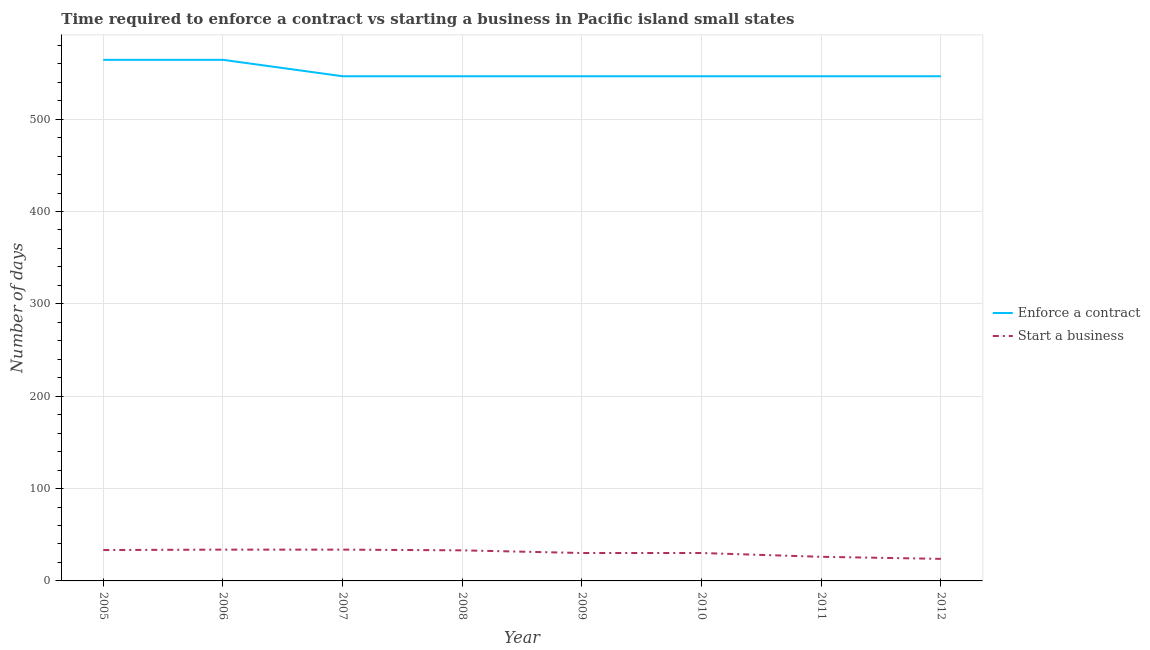How many different coloured lines are there?
Your answer should be compact. 2. Is the number of lines equal to the number of legend labels?
Ensure brevity in your answer.  Yes. What is the number of days to enforece a contract in 2006?
Your answer should be very brief. 564.22. Across all years, what is the maximum number of days to enforece a contract?
Provide a succinct answer. 564.22. Across all years, what is the minimum number of days to start a business?
Offer a terse response. 23.89. In which year was the number of days to enforece a contract maximum?
Make the answer very short. 2005. What is the total number of days to start a business in the graph?
Make the answer very short. 244.78. What is the difference between the number of days to start a business in 2006 and that in 2007?
Provide a succinct answer. 0. What is the difference between the number of days to enforece a contract in 2007 and the number of days to start a business in 2008?
Make the answer very short. 513.33. What is the average number of days to start a business per year?
Provide a short and direct response. 30.6. In the year 2007, what is the difference between the number of days to start a business and number of days to enforece a contract?
Ensure brevity in your answer.  -512.56. What is the ratio of the number of days to start a business in 2010 to that in 2012?
Your answer should be very brief. 1.27. What is the difference between the highest and the lowest number of days to enforece a contract?
Ensure brevity in your answer.  17.78. In how many years, is the number of days to enforece a contract greater than the average number of days to enforece a contract taken over all years?
Ensure brevity in your answer.  2. Is the sum of the number of days to enforece a contract in 2008 and 2012 greater than the maximum number of days to start a business across all years?
Provide a succinct answer. Yes. Is the number of days to start a business strictly greater than the number of days to enforece a contract over the years?
Give a very brief answer. No. Is the number of days to start a business strictly less than the number of days to enforece a contract over the years?
Make the answer very short. Yes. How many lines are there?
Make the answer very short. 2. How many years are there in the graph?
Your response must be concise. 8. What is the difference between two consecutive major ticks on the Y-axis?
Give a very brief answer. 100. Are the values on the major ticks of Y-axis written in scientific E-notation?
Keep it short and to the point. No. Does the graph contain any zero values?
Your answer should be compact. No. Where does the legend appear in the graph?
Provide a short and direct response. Center right. What is the title of the graph?
Make the answer very short. Time required to enforce a contract vs starting a business in Pacific island small states. What is the label or title of the X-axis?
Offer a terse response. Year. What is the label or title of the Y-axis?
Your response must be concise. Number of days. What is the Number of days of Enforce a contract in 2005?
Offer a terse response. 564.22. What is the Number of days in Start a business in 2005?
Your response must be concise. 33.44. What is the Number of days in Enforce a contract in 2006?
Keep it short and to the point. 564.22. What is the Number of days in Start a business in 2006?
Offer a terse response. 33.89. What is the Number of days of Enforce a contract in 2007?
Offer a terse response. 546.44. What is the Number of days in Start a business in 2007?
Ensure brevity in your answer.  33.89. What is the Number of days in Enforce a contract in 2008?
Your answer should be very brief. 546.44. What is the Number of days of Start a business in 2008?
Ensure brevity in your answer.  33.11. What is the Number of days in Enforce a contract in 2009?
Provide a succinct answer. 546.44. What is the Number of days of Start a business in 2009?
Provide a succinct answer. 30.22. What is the Number of days in Enforce a contract in 2010?
Your response must be concise. 546.44. What is the Number of days in Start a business in 2010?
Offer a very short reply. 30.22. What is the Number of days of Enforce a contract in 2011?
Your response must be concise. 546.44. What is the Number of days of Start a business in 2011?
Provide a succinct answer. 26.11. What is the Number of days in Enforce a contract in 2012?
Your answer should be very brief. 546.44. What is the Number of days of Start a business in 2012?
Offer a very short reply. 23.89. Across all years, what is the maximum Number of days in Enforce a contract?
Make the answer very short. 564.22. Across all years, what is the maximum Number of days of Start a business?
Give a very brief answer. 33.89. Across all years, what is the minimum Number of days in Enforce a contract?
Your answer should be very brief. 546.44. Across all years, what is the minimum Number of days of Start a business?
Make the answer very short. 23.89. What is the total Number of days of Enforce a contract in the graph?
Your answer should be very brief. 4407.11. What is the total Number of days in Start a business in the graph?
Your answer should be compact. 244.78. What is the difference between the Number of days of Start a business in 2005 and that in 2006?
Offer a very short reply. -0.44. What is the difference between the Number of days in Enforce a contract in 2005 and that in 2007?
Offer a very short reply. 17.78. What is the difference between the Number of days of Start a business in 2005 and that in 2007?
Ensure brevity in your answer.  -0.44. What is the difference between the Number of days in Enforce a contract in 2005 and that in 2008?
Your answer should be compact. 17.78. What is the difference between the Number of days of Enforce a contract in 2005 and that in 2009?
Give a very brief answer. 17.78. What is the difference between the Number of days in Start a business in 2005 and that in 2009?
Give a very brief answer. 3.22. What is the difference between the Number of days of Enforce a contract in 2005 and that in 2010?
Offer a terse response. 17.78. What is the difference between the Number of days of Start a business in 2005 and that in 2010?
Provide a succinct answer. 3.22. What is the difference between the Number of days in Enforce a contract in 2005 and that in 2011?
Ensure brevity in your answer.  17.78. What is the difference between the Number of days of Start a business in 2005 and that in 2011?
Provide a short and direct response. 7.33. What is the difference between the Number of days of Enforce a contract in 2005 and that in 2012?
Offer a terse response. 17.78. What is the difference between the Number of days of Start a business in 2005 and that in 2012?
Your answer should be very brief. 9.56. What is the difference between the Number of days of Enforce a contract in 2006 and that in 2007?
Your answer should be compact. 17.78. What is the difference between the Number of days of Start a business in 2006 and that in 2007?
Provide a succinct answer. 0. What is the difference between the Number of days in Enforce a contract in 2006 and that in 2008?
Make the answer very short. 17.78. What is the difference between the Number of days of Start a business in 2006 and that in 2008?
Ensure brevity in your answer.  0.78. What is the difference between the Number of days in Enforce a contract in 2006 and that in 2009?
Provide a succinct answer. 17.78. What is the difference between the Number of days in Start a business in 2006 and that in 2009?
Your response must be concise. 3.67. What is the difference between the Number of days of Enforce a contract in 2006 and that in 2010?
Provide a short and direct response. 17.78. What is the difference between the Number of days in Start a business in 2006 and that in 2010?
Give a very brief answer. 3.67. What is the difference between the Number of days in Enforce a contract in 2006 and that in 2011?
Keep it short and to the point. 17.78. What is the difference between the Number of days of Start a business in 2006 and that in 2011?
Offer a terse response. 7.78. What is the difference between the Number of days of Enforce a contract in 2006 and that in 2012?
Ensure brevity in your answer.  17.78. What is the difference between the Number of days of Start a business in 2006 and that in 2012?
Your answer should be very brief. 10. What is the difference between the Number of days in Start a business in 2007 and that in 2009?
Provide a succinct answer. 3.67. What is the difference between the Number of days of Enforce a contract in 2007 and that in 2010?
Offer a very short reply. 0. What is the difference between the Number of days of Start a business in 2007 and that in 2010?
Offer a terse response. 3.67. What is the difference between the Number of days in Start a business in 2007 and that in 2011?
Your response must be concise. 7.78. What is the difference between the Number of days of Enforce a contract in 2007 and that in 2012?
Make the answer very short. 0. What is the difference between the Number of days of Start a business in 2007 and that in 2012?
Ensure brevity in your answer.  10. What is the difference between the Number of days of Enforce a contract in 2008 and that in 2009?
Offer a terse response. 0. What is the difference between the Number of days in Start a business in 2008 and that in 2009?
Give a very brief answer. 2.89. What is the difference between the Number of days of Start a business in 2008 and that in 2010?
Make the answer very short. 2.89. What is the difference between the Number of days of Enforce a contract in 2008 and that in 2011?
Make the answer very short. 0. What is the difference between the Number of days of Start a business in 2008 and that in 2011?
Make the answer very short. 7. What is the difference between the Number of days of Enforce a contract in 2008 and that in 2012?
Offer a very short reply. 0. What is the difference between the Number of days of Start a business in 2008 and that in 2012?
Provide a short and direct response. 9.22. What is the difference between the Number of days of Start a business in 2009 and that in 2010?
Provide a succinct answer. 0. What is the difference between the Number of days of Start a business in 2009 and that in 2011?
Ensure brevity in your answer.  4.11. What is the difference between the Number of days of Start a business in 2009 and that in 2012?
Keep it short and to the point. 6.33. What is the difference between the Number of days of Enforce a contract in 2010 and that in 2011?
Make the answer very short. 0. What is the difference between the Number of days in Start a business in 2010 and that in 2011?
Your response must be concise. 4.11. What is the difference between the Number of days in Start a business in 2010 and that in 2012?
Provide a short and direct response. 6.33. What is the difference between the Number of days of Start a business in 2011 and that in 2012?
Keep it short and to the point. 2.22. What is the difference between the Number of days of Enforce a contract in 2005 and the Number of days of Start a business in 2006?
Make the answer very short. 530.33. What is the difference between the Number of days in Enforce a contract in 2005 and the Number of days in Start a business in 2007?
Provide a short and direct response. 530.33. What is the difference between the Number of days in Enforce a contract in 2005 and the Number of days in Start a business in 2008?
Your answer should be compact. 531.11. What is the difference between the Number of days of Enforce a contract in 2005 and the Number of days of Start a business in 2009?
Your answer should be compact. 534. What is the difference between the Number of days of Enforce a contract in 2005 and the Number of days of Start a business in 2010?
Your response must be concise. 534. What is the difference between the Number of days of Enforce a contract in 2005 and the Number of days of Start a business in 2011?
Your response must be concise. 538.11. What is the difference between the Number of days of Enforce a contract in 2005 and the Number of days of Start a business in 2012?
Provide a short and direct response. 540.33. What is the difference between the Number of days of Enforce a contract in 2006 and the Number of days of Start a business in 2007?
Keep it short and to the point. 530.33. What is the difference between the Number of days of Enforce a contract in 2006 and the Number of days of Start a business in 2008?
Your answer should be compact. 531.11. What is the difference between the Number of days of Enforce a contract in 2006 and the Number of days of Start a business in 2009?
Keep it short and to the point. 534. What is the difference between the Number of days in Enforce a contract in 2006 and the Number of days in Start a business in 2010?
Your response must be concise. 534. What is the difference between the Number of days in Enforce a contract in 2006 and the Number of days in Start a business in 2011?
Your answer should be compact. 538.11. What is the difference between the Number of days in Enforce a contract in 2006 and the Number of days in Start a business in 2012?
Your answer should be very brief. 540.33. What is the difference between the Number of days in Enforce a contract in 2007 and the Number of days in Start a business in 2008?
Your answer should be very brief. 513.33. What is the difference between the Number of days in Enforce a contract in 2007 and the Number of days in Start a business in 2009?
Offer a terse response. 516.22. What is the difference between the Number of days in Enforce a contract in 2007 and the Number of days in Start a business in 2010?
Ensure brevity in your answer.  516.22. What is the difference between the Number of days of Enforce a contract in 2007 and the Number of days of Start a business in 2011?
Give a very brief answer. 520.33. What is the difference between the Number of days of Enforce a contract in 2007 and the Number of days of Start a business in 2012?
Make the answer very short. 522.56. What is the difference between the Number of days in Enforce a contract in 2008 and the Number of days in Start a business in 2009?
Provide a short and direct response. 516.22. What is the difference between the Number of days in Enforce a contract in 2008 and the Number of days in Start a business in 2010?
Provide a short and direct response. 516.22. What is the difference between the Number of days in Enforce a contract in 2008 and the Number of days in Start a business in 2011?
Provide a succinct answer. 520.33. What is the difference between the Number of days in Enforce a contract in 2008 and the Number of days in Start a business in 2012?
Offer a very short reply. 522.56. What is the difference between the Number of days of Enforce a contract in 2009 and the Number of days of Start a business in 2010?
Offer a very short reply. 516.22. What is the difference between the Number of days in Enforce a contract in 2009 and the Number of days in Start a business in 2011?
Your answer should be very brief. 520.33. What is the difference between the Number of days of Enforce a contract in 2009 and the Number of days of Start a business in 2012?
Ensure brevity in your answer.  522.56. What is the difference between the Number of days of Enforce a contract in 2010 and the Number of days of Start a business in 2011?
Your answer should be compact. 520.33. What is the difference between the Number of days in Enforce a contract in 2010 and the Number of days in Start a business in 2012?
Give a very brief answer. 522.56. What is the difference between the Number of days of Enforce a contract in 2011 and the Number of days of Start a business in 2012?
Ensure brevity in your answer.  522.56. What is the average Number of days in Enforce a contract per year?
Offer a very short reply. 550.89. What is the average Number of days of Start a business per year?
Provide a short and direct response. 30.6. In the year 2005, what is the difference between the Number of days of Enforce a contract and Number of days of Start a business?
Keep it short and to the point. 530.78. In the year 2006, what is the difference between the Number of days in Enforce a contract and Number of days in Start a business?
Your answer should be very brief. 530.33. In the year 2007, what is the difference between the Number of days in Enforce a contract and Number of days in Start a business?
Provide a succinct answer. 512.56. In the year 2008, what is the difference between the Number of days in Enforce a contract and Number of days in Start a business?
Provide a succinct answer. 513.33. In the year 2009, what is the difference between the Number of days of Enforce a contract and Number of days of Start a business?
Your answer should be compact. 516.22. In the year 2010, what is the difference between the Number of days in Enforce a contract and Number of days in Start a business?
Keep it short and to the point. 516.22. In the year 2011, what is the difference between the Number of days of Enforce a contract and Number of days of Start a business?
Make the answer very short. 520.33. In the year 2012, what is the difference between the Number of days in Enforce a contract and Number of days in Start a business?
Keep it short and to the point. 522.56. What is the ratio of the Number of days of Start a business in 2005 to that in 2006?
Offer a terse response. 0.99. What is the ratio of the Number of days in Enforce a contract in 2005 to that in 2007?
Offer a very short reply. 1.03. What is the ratio of the Number of days of Start a business in 2005 to that in 2007?
Ensure brevity in your answer.  0.99. What is the ratio of the Number of days in Enforce a contract in 2005 to that in 2008?
Offer a terse response. 1.03. What is the ratio of the Number of days of Start a business in 2005 to that in 2008?
Your answer should be compact. 1.01. What is the ratio of the Number of days of Enforce a contract in 2005 to that in 2009?
Give a very brief answer. 1.03. What is the ratio of the Number of days in Start a business in 2005 to that in 2009?
Provide a succinct answer. 1.11. What is the ratio of the Number of days in Enforce a contract in 2005 to that in 2010?
Offer a terse response. 1.03. What is the ratio of the Number of days of Start a business in 2005 to that in 2010?
Keep it short and to the point. 1.11. What is the ratio of the Number of days of Enforce a contract in 2005 to that in 2011?
Give a very brief answer. 1.03. What is the ratio of the Number of days in Start a business in 2005 to that in 2011?
Offer a terse response. 1.28. What is the ratio of the Number of days in Enforce a contract in 2005 to that in 2012?
Ensure brevity in your answer.  1.03. What is the ratio of the Number of days of Start a business in 2005 to that in 2012?
Offer a very short reply. 1.4. What is the ratio of the Number of days in Enforce a contract in 2006 to that in 2007?
Offer a terse response. 1.03. What is the ratio of the Number of days in Enforce a contract in 2006 to that in 2008?
Ensure brevity in your answer.  1.03. What is the ratio of the Number of days in Start a business in 2006 to that in 2008?
Offer a terse response. 1.02. What is the ratio of the Number of days in Enforce a contract in 2006 to that in 2009?
Ensure brevity in your answer.  1.03. What is the ratio of the Number of days of Start a business in 2006 to that in 2009?
Your response must be concise. 1.12. What is the ratio of the Number of days of Enforce a contract in 2006 to that in 2010?
Your answer should be compact. 1.03. What is the ratio of the Number of days in Start a business in 2006 to that in 2010?
Your answer should be very brief. 1.12. What is the ratio of the Number of days in Enforce a contract in 2006 to that in 2011?
Provide a succinct answer. 1.03. What is the ratio of the Number of days of Start a business in 2006 to that in 2011?
Make the answer very short. 1.3. What is the ratio of the Number of days in Enforce a contract in 2006 to that in 2012?
Provide a succinct answer. 1.03. What is the ratio of the Number of days in Start a business in 2006 to that in 2012?
Offer a terse response. 1.42. What is the ratio of the Number of days of Enforce a contract in 2007 to that in 2008?
Make the answer very short. 1. What is the ratio of the Number of days in Start a business in 2007 to that in 2008?
Your answer should be very brief. 1.02. What is the ratio of the Number of days of Enforce a contract in 2007 to that in 2009?
Provide a short and direct response. 1. What is the ratio of the Number of days of Start a business in 2007 to that in 2009?
Provide a short and direct response. 1.12. What is the ratio of the Number of days in Start a business in 2007 to that in 2010?
Keep it short and to the point. 1.12. What is the ratio of the Number of days in Start a business in 2007 to that in 2011?
Your answer should be very brief. 1.3. What is the ratio of the Number of days of Enforce a contract in 2007 to that in 2012?
Keep it short and to the point. 1. What is the ratio of the Number of days in Start a business in 2007 to that in 2012?
Make the answer very short. 1.42. What is the ratio of the Number of days in Enforce a contract in 2008 to that in 2009?
Your answer should be compact. 1. What is the ratio of the Number of days in Start a business in 2008 to that in 2009?
Provide a succinct answer. 1.1. What is the ratio of the Number of days of Start a business in 2008 to that in 2010?
Keep it short and to the point. 1.1. What is the ratio of the Number of days of Enforce a contract in 2008 to that in 2011?
Your response must be concise. 1. What is the ratio of the Number of days in Start a business in 2008 to that in 2011?
Your answer should be compact. 1.27. What is the ratio of the Number of days in Enforce a contract in 2008 to that in 2012?
Give a very brief answer. 1. What is the ratio of the Number of days in Start a business in 2008 to that in 2012?
Provide a short and direct response. 1.39. What is the ratio of the Number of days in Enforce a contract in 2009 to that in 2010?
Make the answer very short. 1. What is the ratio of the Number of days of Start a business in 2009 to that in 2010?
Offer a terse response. 1. What is the ratio of the Number of days of Start a business in 2009 to that in 2011?
Give a very brief answer. 1.16. What is the ratio of the Number of days in Enforce a contract in 2009 to that in 2012?
Your answer should be very brief. 1. What is the ratio of the Number of days of Start a business in 2009 to that in 2012?
Offer a terse response. 1.27. What is the ratio of the Number of days of Enforce a contract in 2010 to that in 2011?
Provide a short and direct response. 1. What is the ratio of the Number of days of Start a business in 2010 to that in 2011?
Your response must be concise. 1.16. What is the ratio of the Number of days of Start a business in 2010 to that in 2012?
Make the answer very short. 1.27. What is the ratio of the Number of days of Enforce a contract in 2011 to that in 2012?
Your response must be concise. 1. What is the ratio of the Number of days in Start a business in 2011 to that in 2012?
Keep it short and to the point. 1.09. What is the difference between the highest and the lowest Number of days of Enforce a contract?
Your response must be concise. 17.78. 